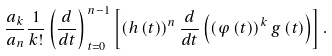Convert formula to latex. <formula><loc_0><loc_0><loc_500><loc_500>\frac { a _ { k } } { a _ { n } } \frac { 1 } { k ! } \left ( \frac { d } { d t } \right ) _ { \, t = 0 } ^ { \, n - 1 } \left [ \left ( h \left ( t \right ) \right ) ^ { n } \frac { d } { d t } \left ( \left ( \varphi \left ( t \right ) \right ) ^ { k } g \left ( t \right ) \right ) \right ] .</formula> 